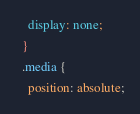<code> <loc_0><loc_0><loc_500><loc_500><_CSS_>    display: none;
  }
  .media {
    position: absolute;</code> 